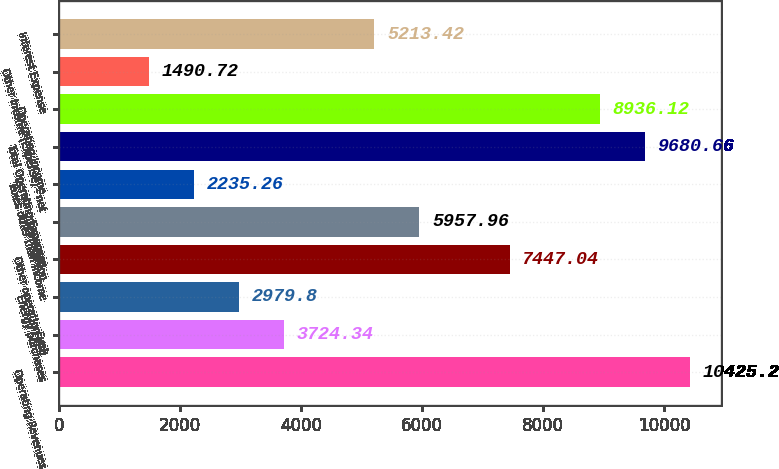<chart> <loc_0><loc_0><loc_500><loc_500><bar_chart><fcel>Operating Revenues<fcel>Fuel<fcel>Energy purchases<fcel>Other operation and<fcel>Depreciation<fcel>Taxes other than income<fcel>Total Operating Expenses<fcel>Operating Income<fcel>Other Income (Expense) - net<fcel>Interest Expense<nl><fcel>10425.2<fcel>3724.34<fcel>2979.8<fcel>7447.04<fcel>5957.96<fcel>2235.26<fcel>9680.66<fcel>8936.12<fcel>1490.72<fcel>5213.42<nl></chart> 